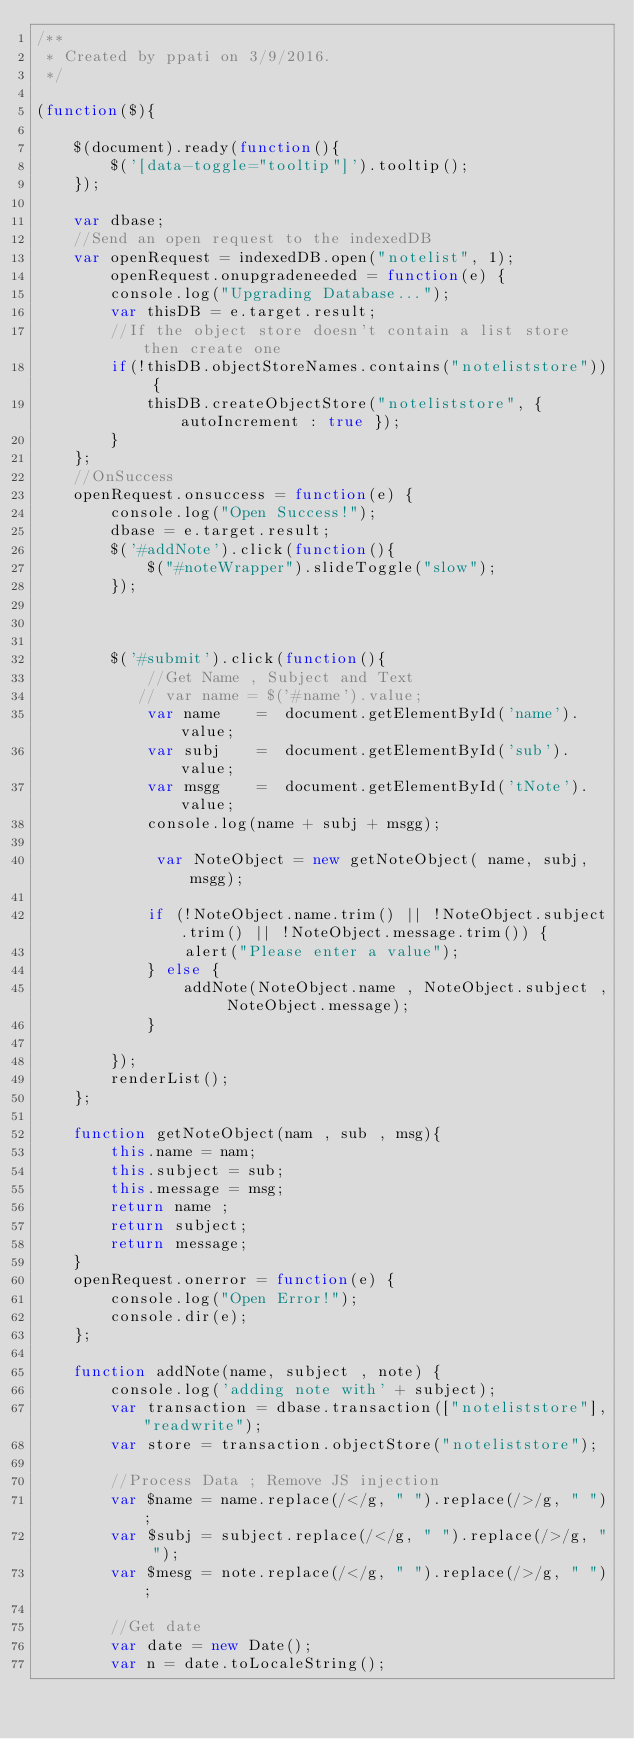Convert code to text. <code><loc_0><loc_0><loc_500><loc_500><_JavaScript_>/**
 * Created by ppati on 3/9/2016.
 */

(function($){

    $(document).ready(function(){
        $('[data-toggle="tooltip"]').tooltip();
    });

    var dbase;
    //Send an open request to the indexedDB
    var openRequest = indexedDB.open("notelist", 1);
        openRequest.onupgradeneeded = function(e) {
        console.log("Upgrading Database...");
        var thisDB = e.target.result;
        //If the object store doesn't contain a list store then create one
        if(!thisDB.objectStoreNames.contains("noteliststore")) {
            thisDB.createObjectStore("noteliststore", { autoIncrement : true });
        }
    };
    //OnSuccess
    openRequest.onsuccess = function(e) {
        console.log("Open Success!");
        dbase = e.target.result;
        $('#addNote').click(function(){
            $("#noteWrapper").slideToggle("slow");
        });



        $('#submit').click(function(){
            //Get Name , Subject and Text
           // var name = $('#name').value;
            var name    =  document.getElementById('name').value;
            var subj    =  document.getElementById('sub').value;
            var msgg    =  document.getElementById('tNote').value;
            console.log(name + subj + msgg);

             var NoteObject = new getNoteObject( name, subj, msgg);

            if (!NoteObject.name.trim() || !NoteObject.subject.trim() || !NoteObject.message.trim()) {
                alert("Please enter a value");
            } else {
                addNote(NoteObject.name , NoteObject.subject , NoteObject.message);
            }

        });
        renderList();
    };

    function getNoteObject(nam , sub , msg){
        this.name = nam;
        this.subject = sub;
        this.message = msg;
        return name ;
        return subject;
        return message;
    }
    openRequest.onerror = function(e) {
        console.log("Open Error!");
        console.dir(e);
    };

    function addNote(name, subject , note) {
        console.log('adding note with' + subject);
        var transaction = dbase.transaction(["noteliststore"],"readwrite");
        var store = transaction.objectStore("noteliststore");

        //Process Data ; Remove JS injection
        var $name = name.replace(/</g, " ").replace(/>/g, " ");
        var $subj = subject.replace(/</g, " ").replace(/>/g, " ");
        var $mesg = note.replace(/</g, " ").replace(/>/g, " ");

        //Get date
        var date = new Date();
        var n = date.toLocaleString();
</code> 